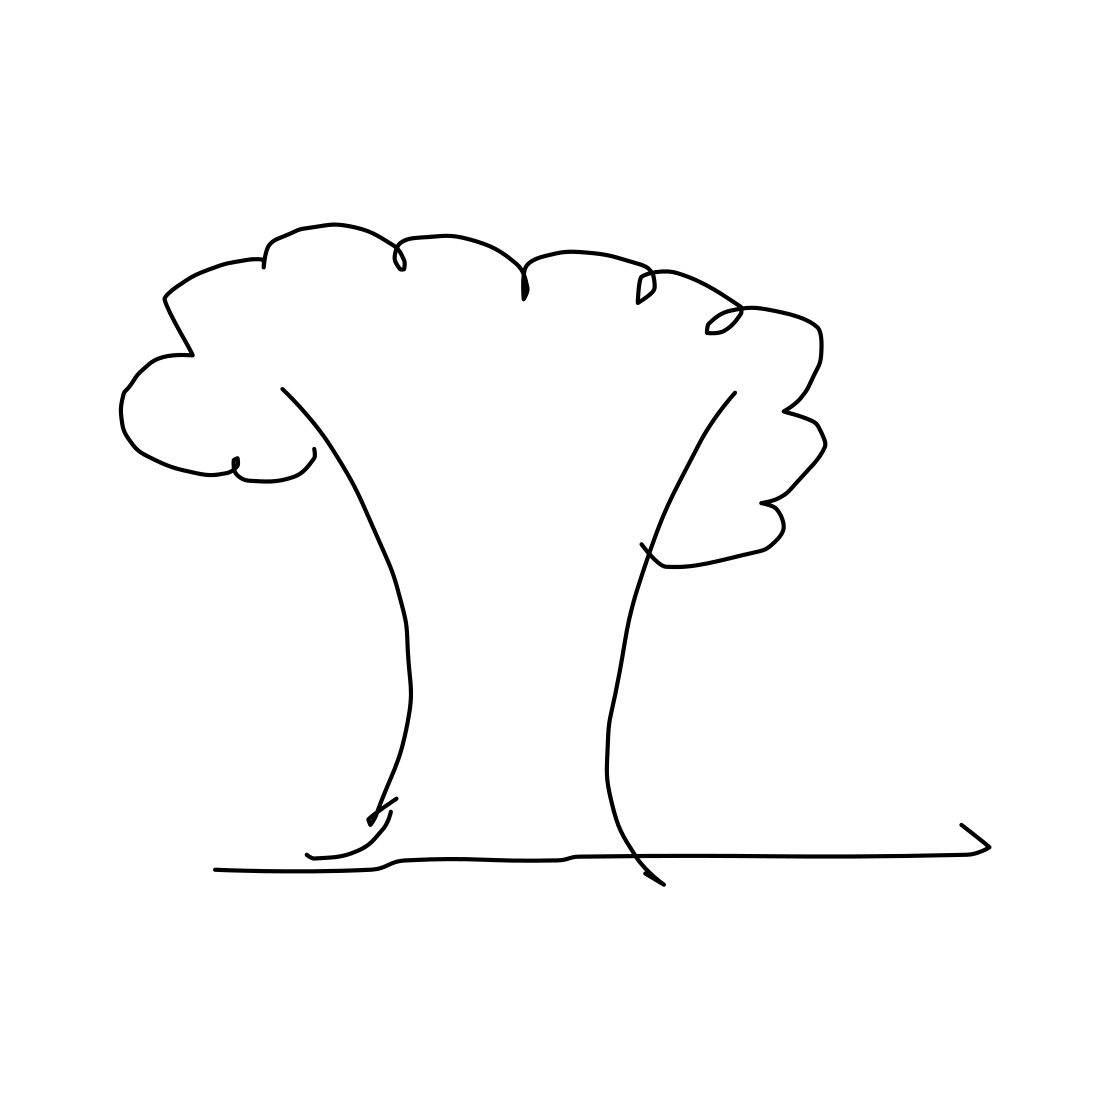Does this tree drawing look like it belongs to any particular culture or tradition? Given the simplicity of the drawing, it's challenging to attribute it to a specific culture or tradition. The lack of intricate patterns or distinct elements makes it quite universal, but it could be reminiscent of a child's artwork or simple educational illustrations. 